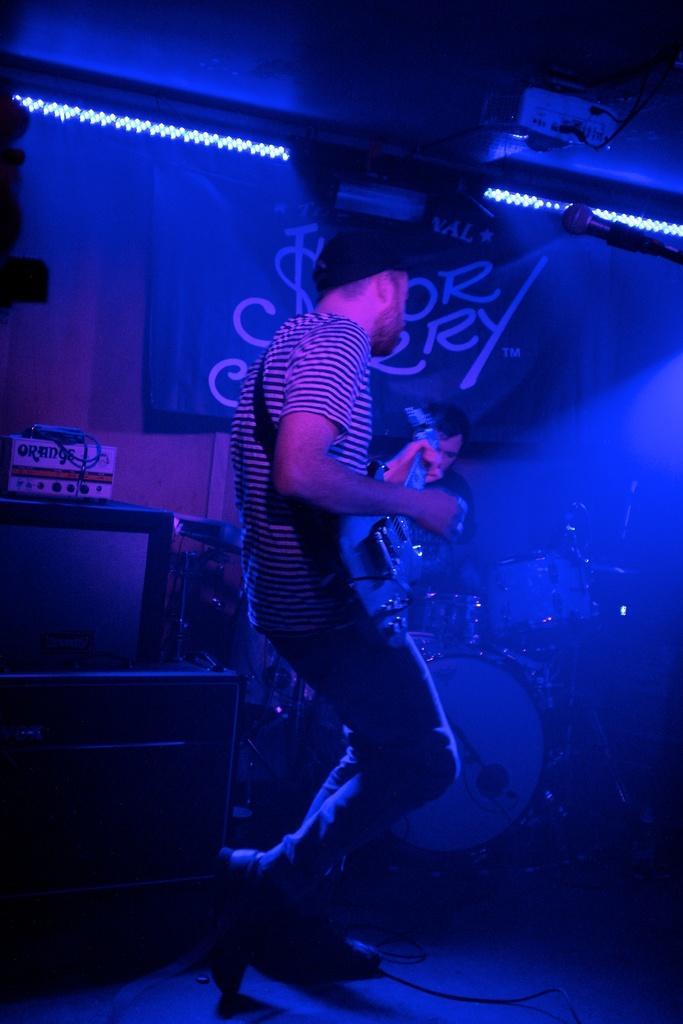How would you summarize this image in a sentence or two? In this image we can see a person and a musical instrument. In the background of the image there is a person, television, board and other objects. At the top of the image there is the ceiling, projector, lights and other objects. On the right side of the image there is a microphone. At the bottom of the image there is the floor. 